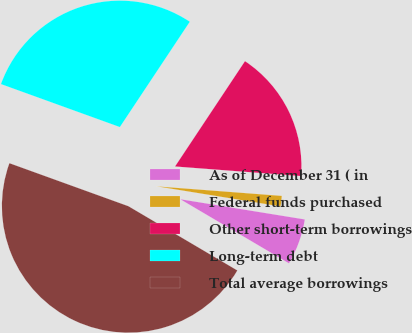Convert chart to OTSL. <chart><loc_0><loc_0><loc_500><loc_500><pie_chart><fcel>As of December 31 ( in<fcel>Federal funds purchased<fcel>Other short-term borrowings<fcel>Long-term debt<fcel>Total average borrowings<nl><fcel>5.92%<fcel>1.35%<fcel>16.88%<fcel>28.81%<fcel>47.04%<nl></chart> 